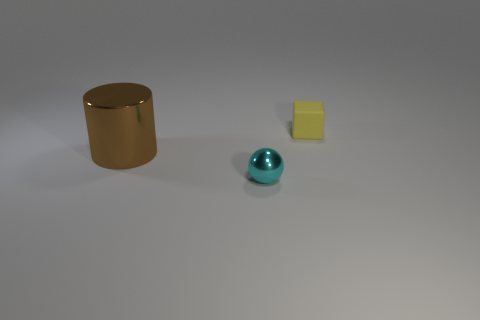Is the size of the brown metallic cylinder the same as the object on the right side of the tiny cyan object?
Offer a terse response. No. Are there any other things that have the same material as the cyan sphere?
Keep it short and to the point. Yes. Do the metal thing that is in front of the brown object and the yellow matte object that is to the right of the metal cylinder have the same size?
Keep it short and to the point. Yes. What number of large objects are either blue cubes or rubber blocks?
Your answer should be compact. 0. What number of objects are both on the right side of the big cylinder and to the left of the small block?
Offer a terse response. 1. Does the tiny cyan ball have the same material as the thing behind the brown cylinder?
Provide a succinct answer. No. How many purple objects are tiny cubes or metal spheres?
Your response must be concise. 0. Is there a cylinder of the same size as the cyan thing?
Give a very brief answer. No. There is a tiny object that is in front of the shiny object that is behind the shiny object that is in front of the cylinder; what is its material?
Provide a succinct answer. Metal. Is the number of tiny spheres that are in front of the yellow rubber thing the same as the number of purple metallic balls?
Your answer should be very brief. No. 